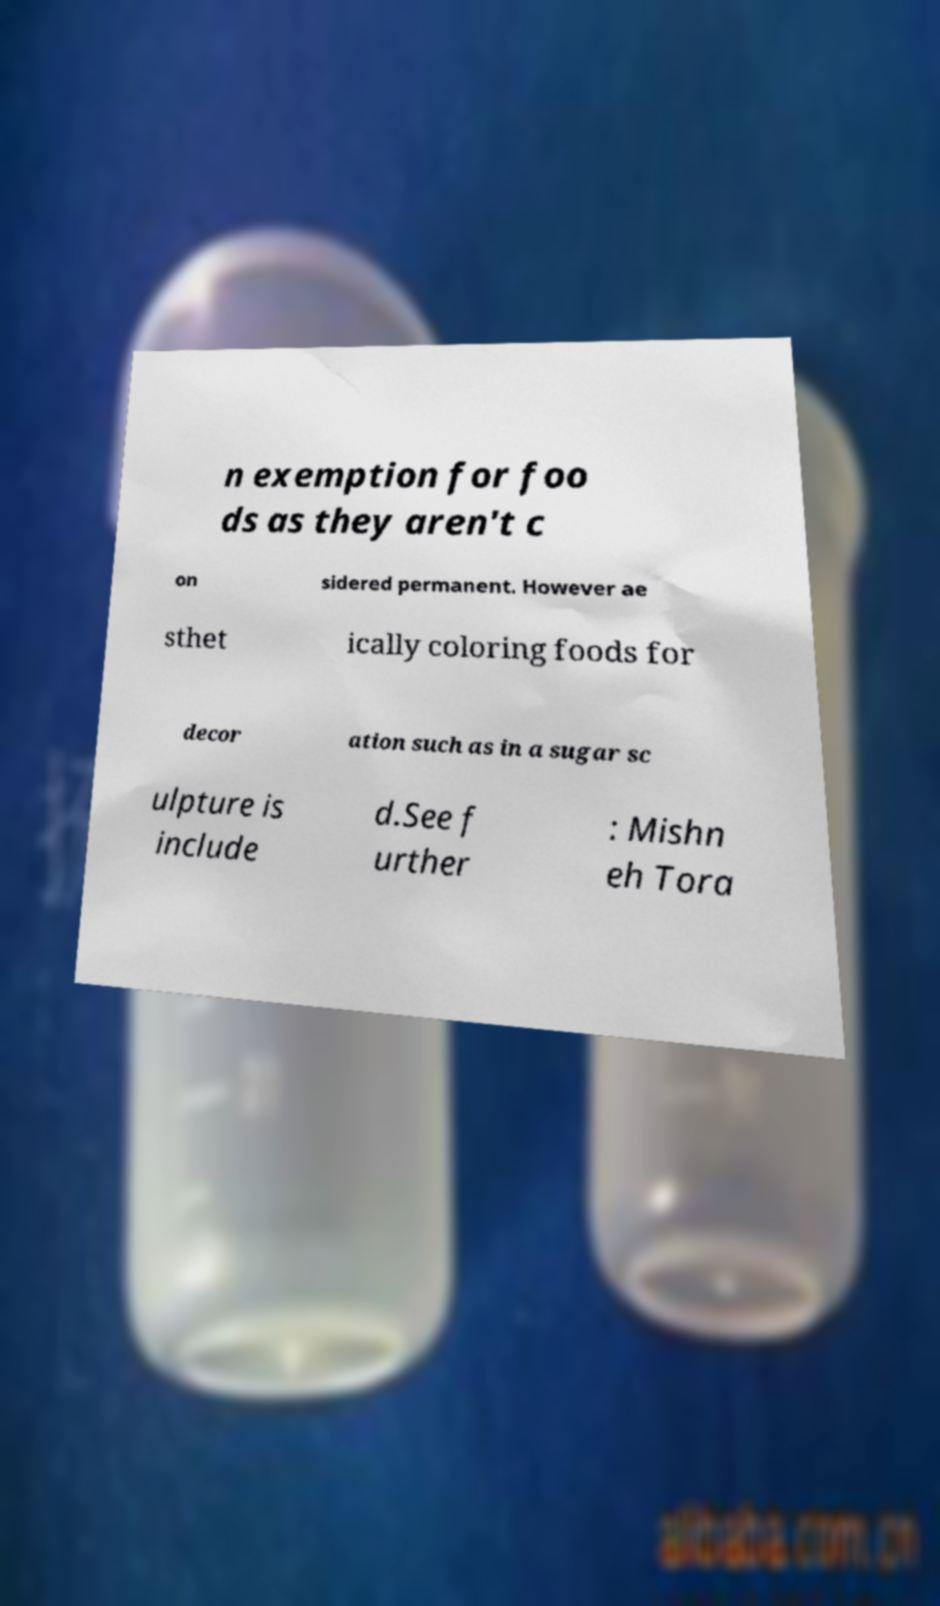Could you assist in decoding the text presented in this image and type it out clearly? n exemption for foo ds as they aren't c on sidered permanent. However ae sthet ically coloring foods for decor ation such as in a sugar sc ulpture is include d.See f urther : Mishn eh Tora 